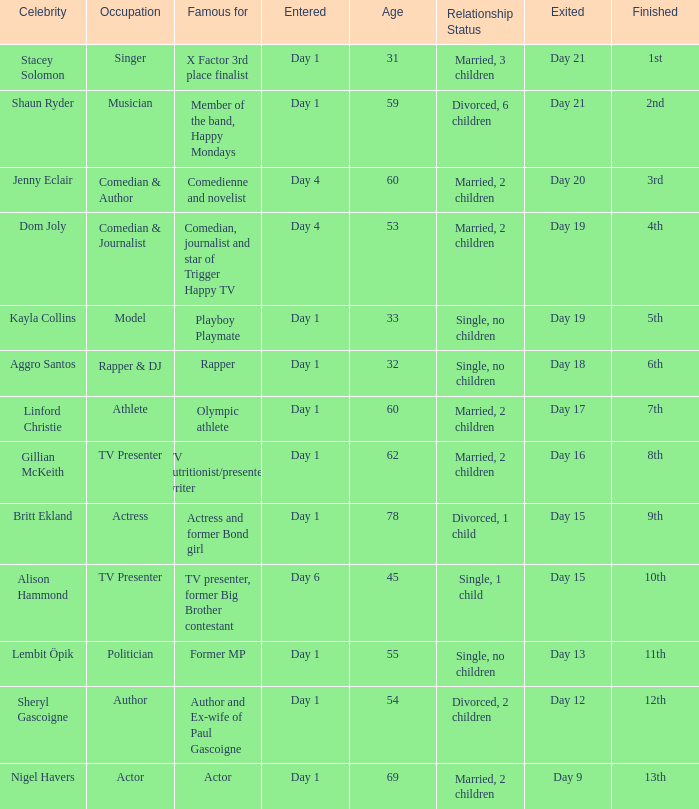What position did the celebrity finish that entered on day 1 and exited on day 15? 9th. 